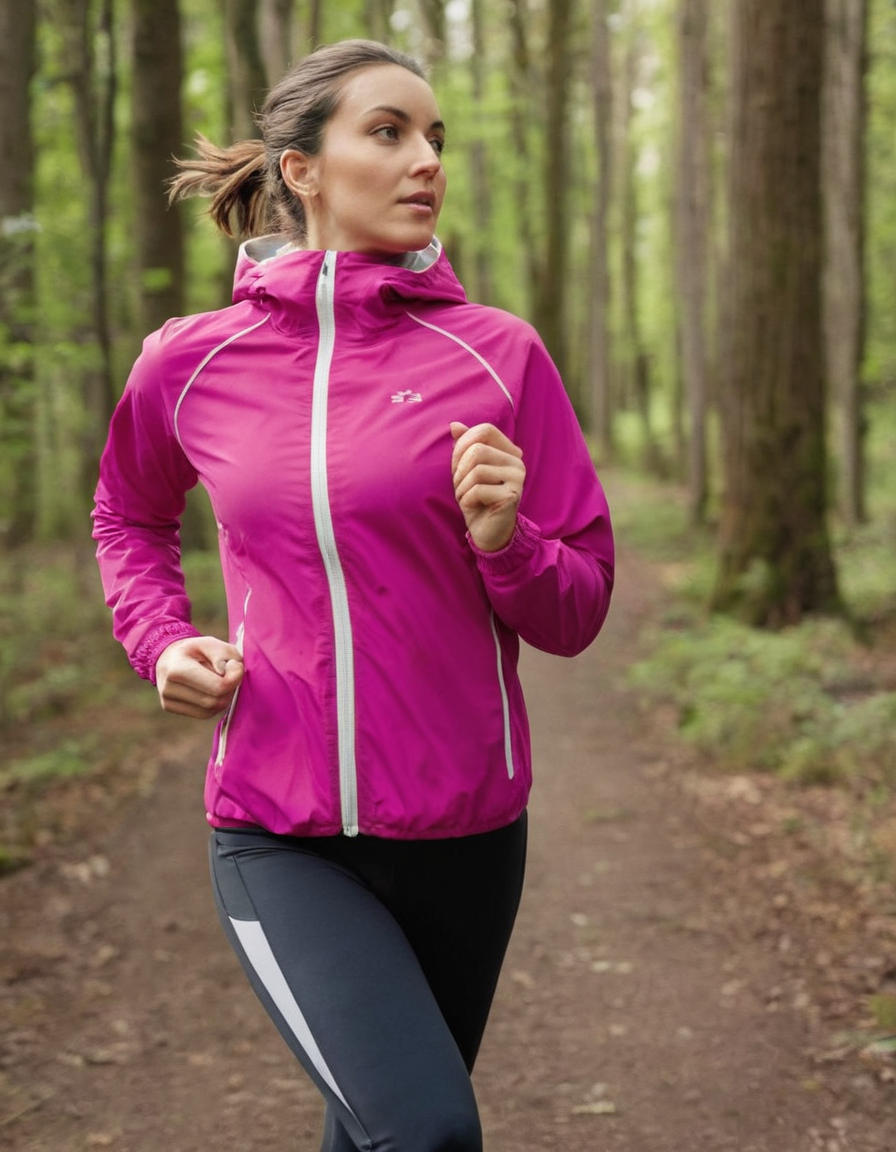Is the following image AI generated? Explain your reasoning. No, this image does not appear to be AI generated. The level of detail, the natural lighting and shadows, and the realistic appearance of the person in the image all suggest that this is a photograph of a real person, rather than an artificially generated image. The image has the characteristics typical of a high-quality photograph taken outdoors in a natural setting, which is not something current AI image generation models are consistently able to produce with such realism and coherence. Based on the visual cues, this seems to be a genuine photograph rather than an AI-generated image. 